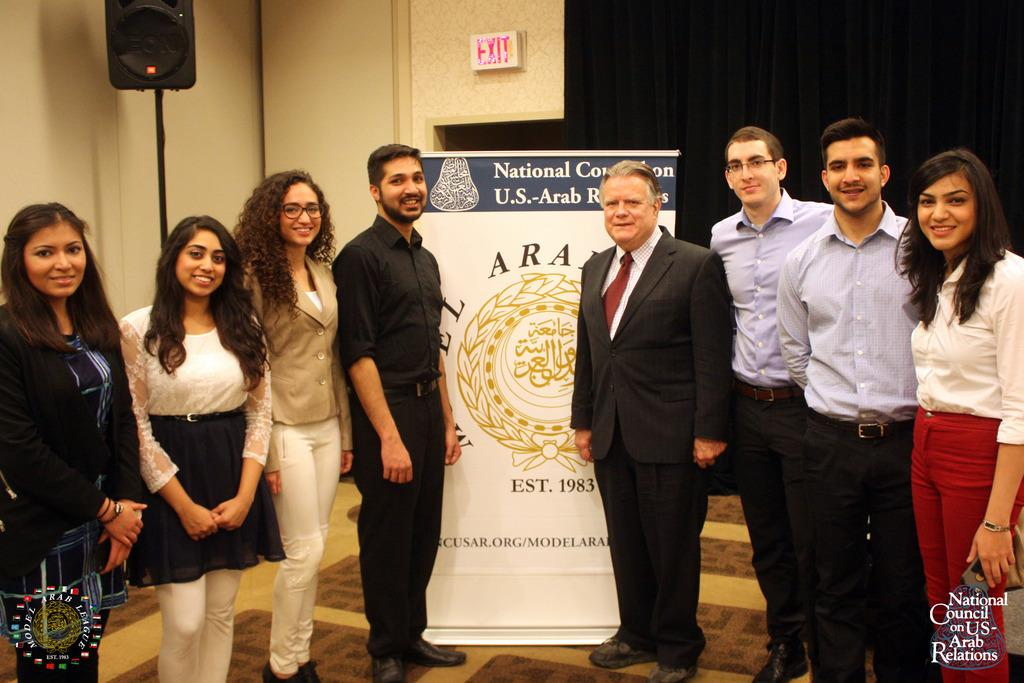How many people are in the group visible in the image? There is a group of people standing in the image, but the exact number cannot be determined from the provided facts. What is written on the banner in the image? The content of the banner cannot be determined from the provided facts. What is the purpose of the board in the image? The purpose of the board in the image cannot be determined from the provided facts. What is the speaker talking about in the image? The topic of the speaker's speech cannot be determined from the provided facts. What color is the curtain in the background of the image? The color of the curtain cannot be determined from the provided facts. What is the resolution of the image? The resolution of the image cannot be determined from the provided facts. How many toes does the farmer have in the image? There is no farmer or mention of toes in the image, so this question cannot be answered. 